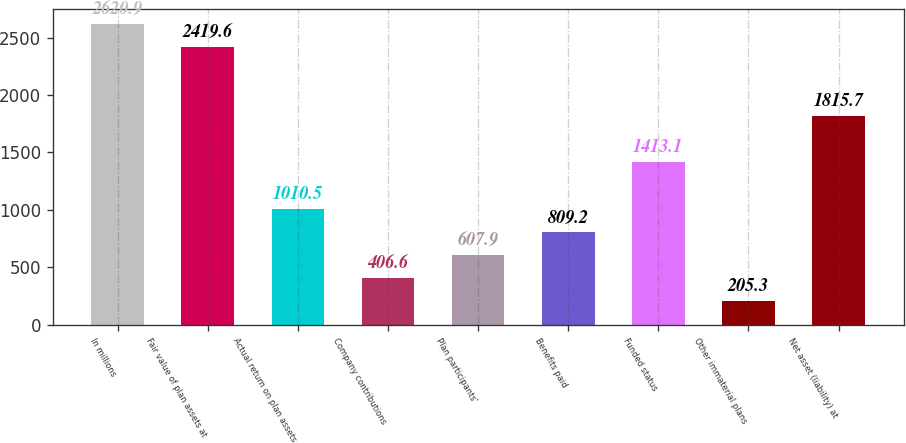<chart> <loc_0><loc_0><loc_500><loc_500><bar_chart><fcel>In millions<fcel>Fair value of plan assets at<fcel>Actual return on plan assets<fcel>Company contributions<fcel>Plan participants'<fcel>Benefits paid<fcel>Funded status<fcel>Other immaterial plans<fcel>Net asset (liability) at<nl><fcel>2620.9<fcel>2419.6<fcel>1010.5<fcel>406.6<fcel>607.9<fcel>809.2<fcel>1413.1<fcel>205.3<fcel>1815.7<nl></chart> 